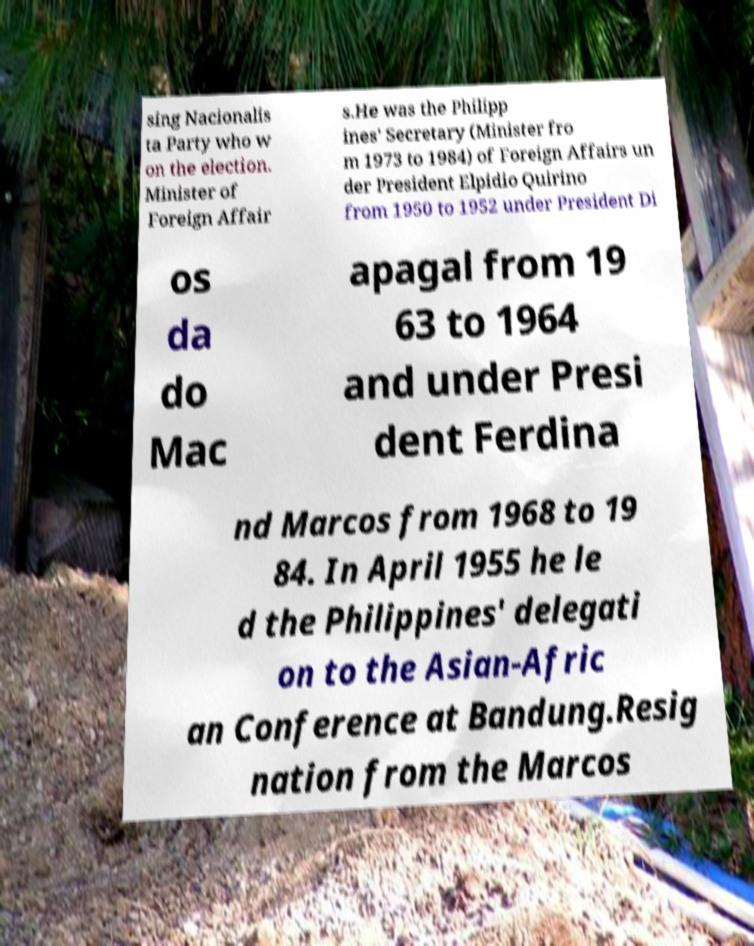For documentation purposes, I need the text within this image transcribed. Could you provide that? sing Nacionalis ta Party who w on the election. Minister of Foreign Affair s.He was the Philipp ines' Secretary (Minister fro m 1973 to 1984) of Foreign Affairs un der President Elpidio Quirino from 1950 to 1952 under President Di os da do Mac apagal from 19 63 to 1964 and under Presi dent Ferdina nd Marcos from 1968 to 19 84. In April 1955 he le d the Philippines' delegati on to the Asian-Afric an Conference at Bandung.Resig nation from the Marcos 